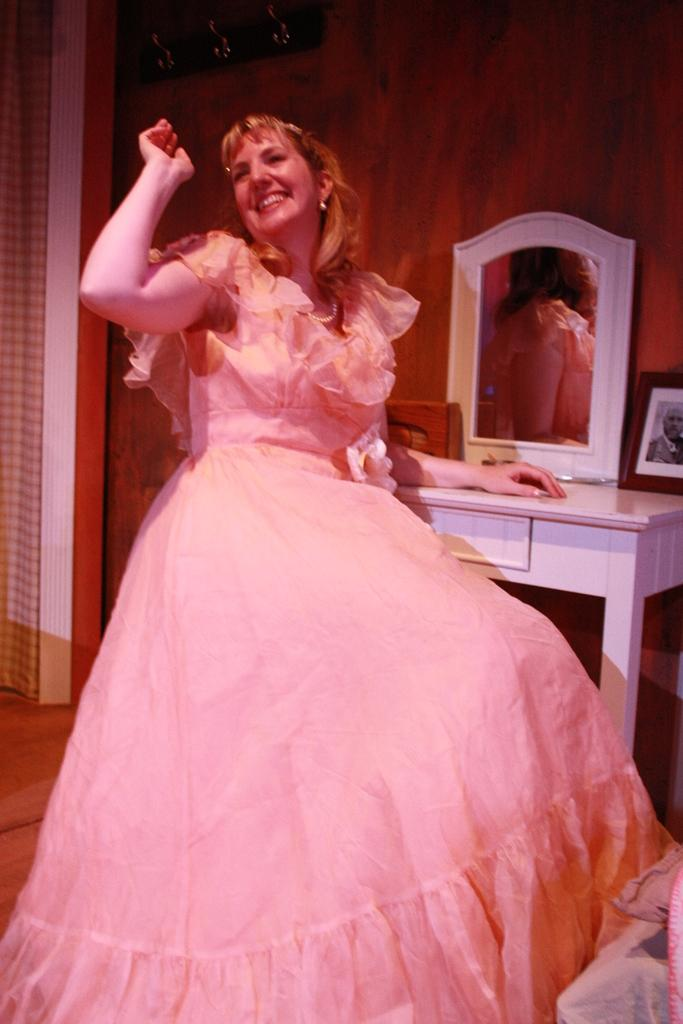What is the main subject of the image? The main subject of the image is a girl. What is the girl doing in the image? The girl is smiling in the image. What object is present in front of the girl? There is a mirror in front of the girl. What type of town can be seen in the background of the image? There is no town visible in the background of the image. What does the girl believe about the cream in the image? There is no mention of cream in the image, so it is not possible to determine what the girl believes about it. 